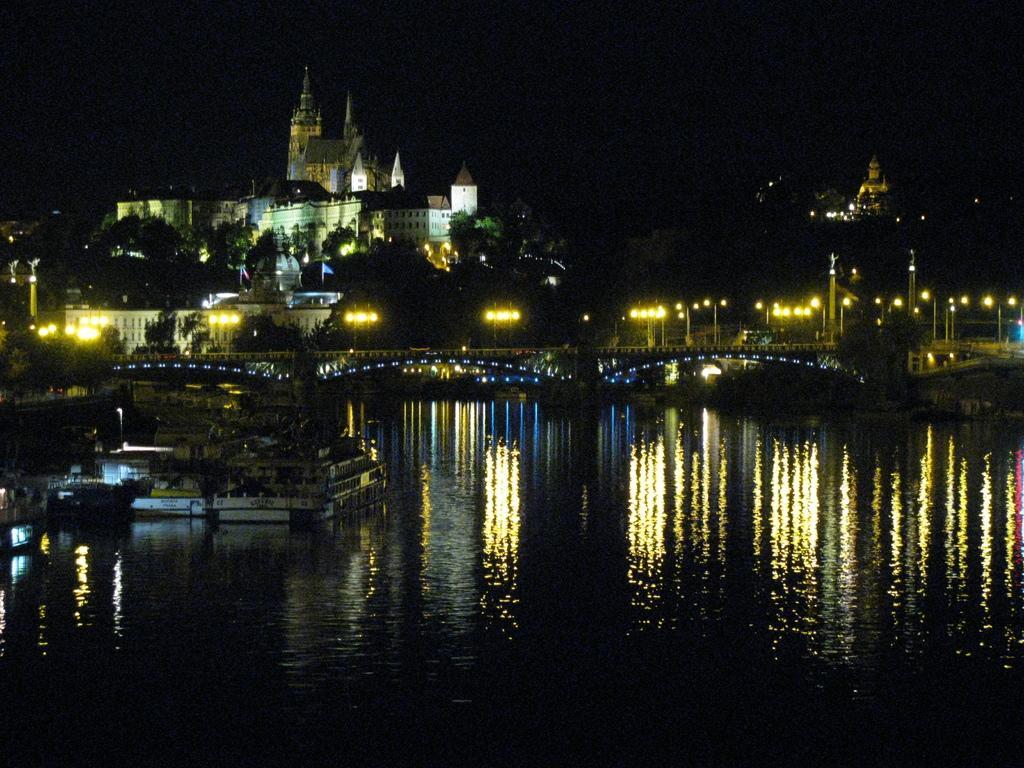Can you describe this image briefly? In this image, we can see a lake. There are street poles on the bridge. There are some trees and buildings in the middle of the image. There is a sky at the top of the image. 